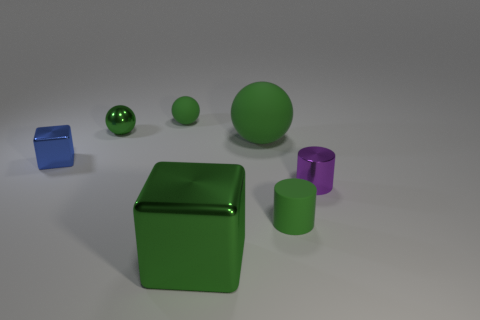The green object that is made of the same material as the green cube is what shape?
Your answer should be very brief. Sphere. How many big things are there?
Your answer should be compact. 2. What number of things are either tiny shiny things that are right of the shiny ball or big yellow rubber spheres?
Keep it short and to the point. 1. Is the color of the shiny block that is in front of the purple object the same as the rubber cylinder?
Offer a very short reply. Yes. How many other objects are the same color as the small matte cylinder?
Offer a very short reply. 4. How many big objects are either green cubes or purple things?
Your answer should be compact. 1. Are there more tiny brown things than small blue metallic blocks?
Offer a terse response. No. Does the big cube have the same material as the tiny purple object?
Ensure brevity in your answer.  Yes. Are there more things that are in front of the tiny blue shiny thing than small yellow matte objects?
Your answer should be compact. Yes. Is the tiny matte cylinder the same color as the large metallic thing?
Give a very brief answer. Yes. 